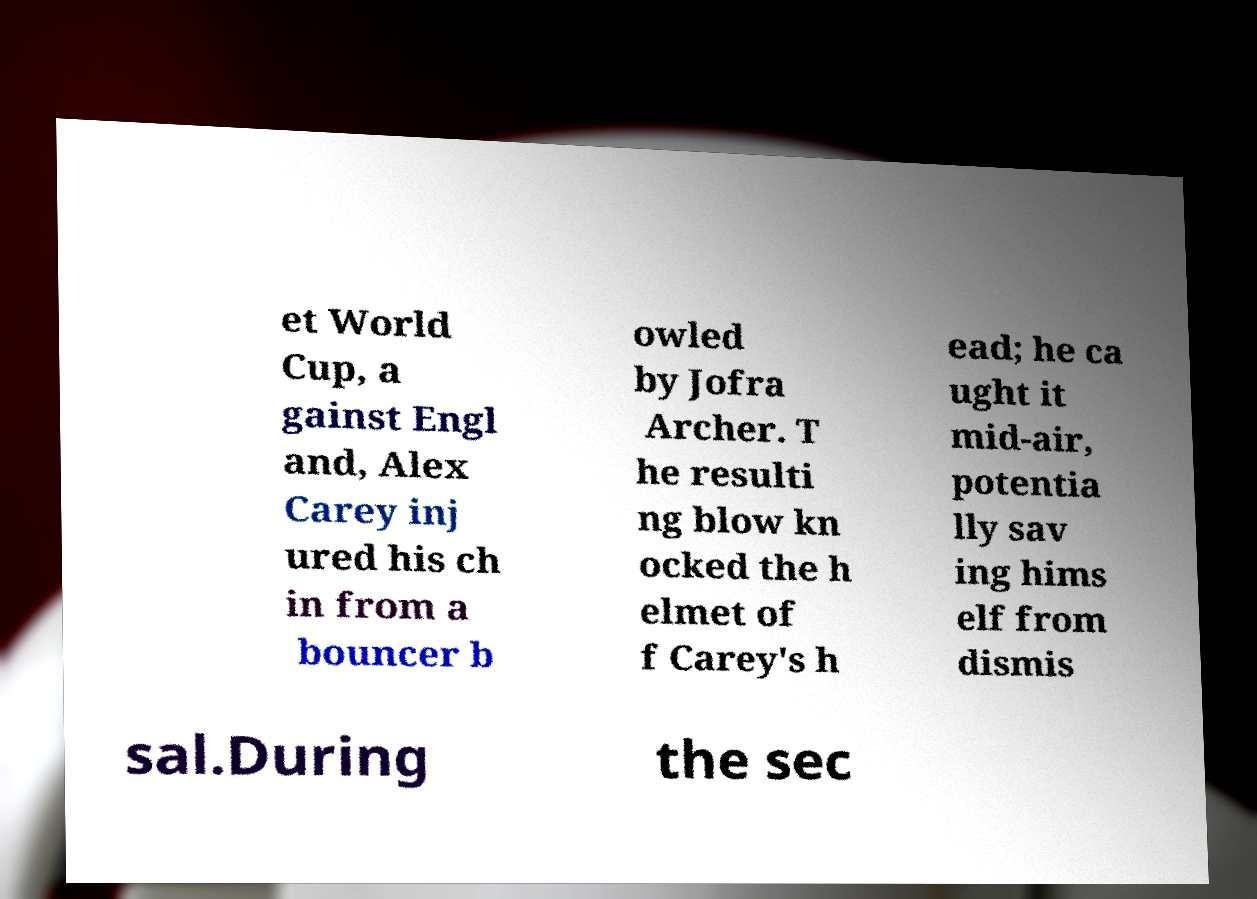Could you extract and type out the text from this image? et World Cup, a gainst Engl and, Alex Carey inj ured his ch in from a bouncer b owled by Jofra Archer. T he resulti ng blow kn ocked the h elmet of f Carey's h ead; he ca ught it mid-air, potentia lly sav ing hims elf from dismis sal.During the sec 